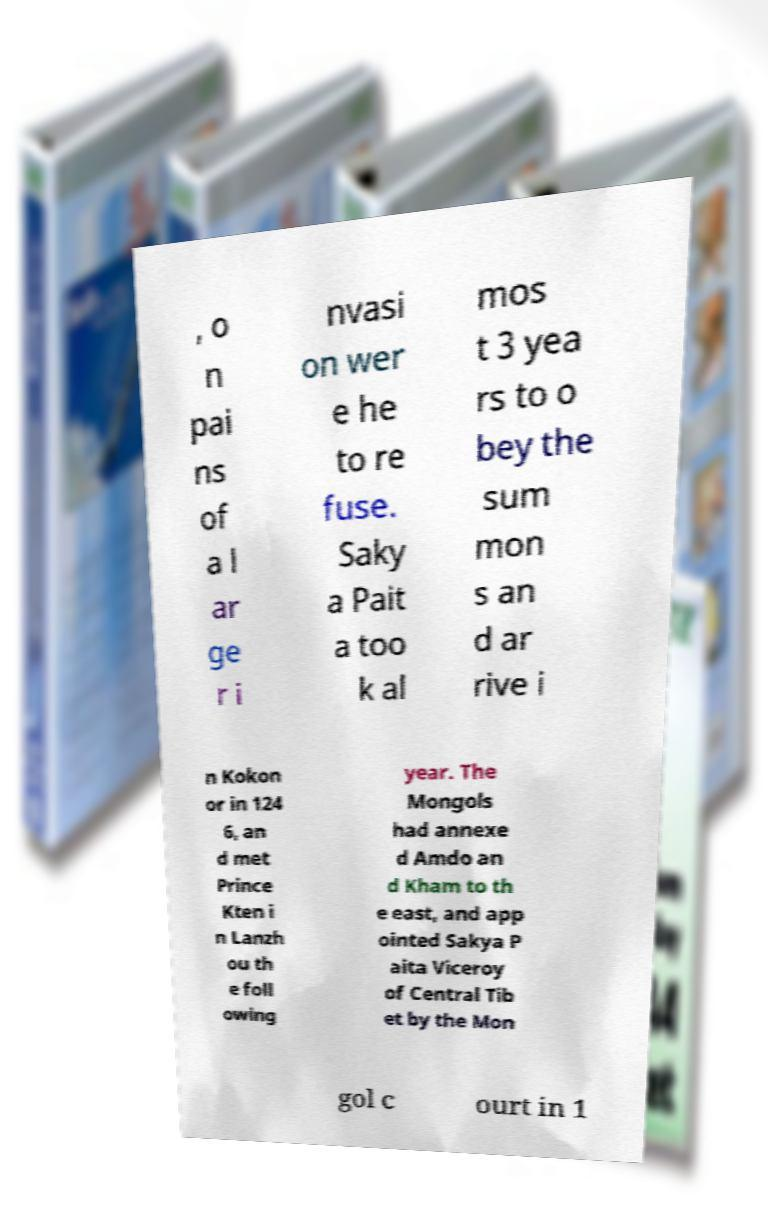Can you read and provide the text displayed in the image?This photo seems to have some interesting text. Can you extract and type it out for me? , o n pai ns of a l ar ge r i nvasi on wer e he to re fuse. Saky a Pait a too k al mos t 3 yea rs to o bey the sum mon s an d ar rive i n Kokon or in 124 6, an d met Prince Kten i n Lanzh ou th e foll owing year. The Mongols had annexe d Amdo an d Kham to th e east, and app ointed Sakya P aita Viceroy of Central Tib et by the Mon gol c ourt in 1 